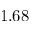Convert formula to latex. <formula><loc_0><loc_0><loc_500><loc_500>1 . 6 8</formula> 